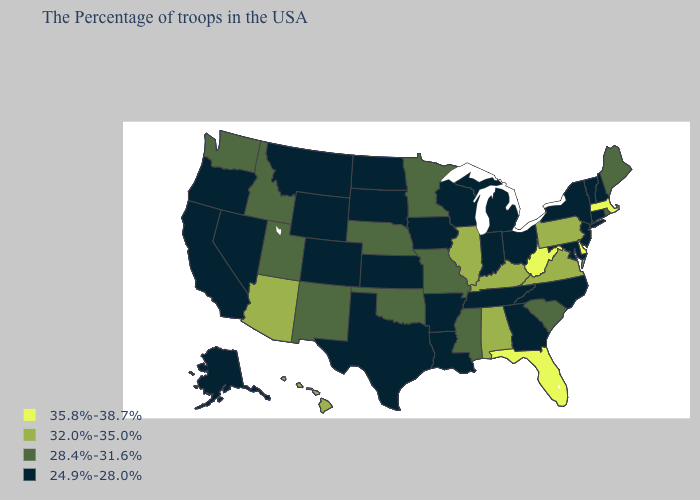What is the value of Alaska?
Quick response, please. 24.9%-28.0%. Name the states that have a value in the range 35.8%-38.7%?
Answer briefly. Massachusetts, Delaware, West Virginia, Florida. Name the states that have a value in the range 28.4%-31.6%?
Write a very short answer. Maine, Rhode Island, South Carolina, Mississippi, Missouri, Minnesota, Nebraska, Oklahoma, New Mexico, Utah, Idaho, Washington. What is the value of Delaware?
Short answer required. 35.8%-38.7%. What is the value of Pennsylvania?
Write a very short answer. 32.0%-35.0%. What is the value of Massachusetts?
Keep it brief. 35.8%-38.7%. Name the states that have a value in the range 32.0%-35.0%?
Quick response, please. Pennsylvania, Virginia, Kentucky, Alabama, Illinois, Arizona, Hawaii. What is the highest value in the South ?
Write a very short answer. 35.8%-38.7%. What is the value of Oklahoma?
Answer briefly. 28.4%-31.6%. Is the legend a continuous bar?
Give a very brief answer. No. What is the value of Arkansas?
Concise answer only. 24.9%-28.0%. Name the states that have a value in the range 28.4%-31.6%?
Be succinct. Maine, Rhode Island, South Carolina, Mississippi, Missouri, Minnesota, Nebraska, Oklahoma, New Mexico, Utah, Idaho, Washington. What is the value of Virginia?
Give a very brief answer. 32.0%-35.0%. What is the value of Nevada?
Short answer required. 24.9%-28.0%. Name the states that have a value in the range 35.8%-38.7%?
Give a very brief answer. Massachusetts, Delaware, West Virginia, Florida. 